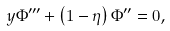Convert formula to latex. <formula><loc_0><loc_0><loc_500><loc_500>y \Phi ^ { \prime \prime \prime } + \left ( 1 - \eta \right ) \Phi ^ { \prime \prime } = 0 ,</formula> 